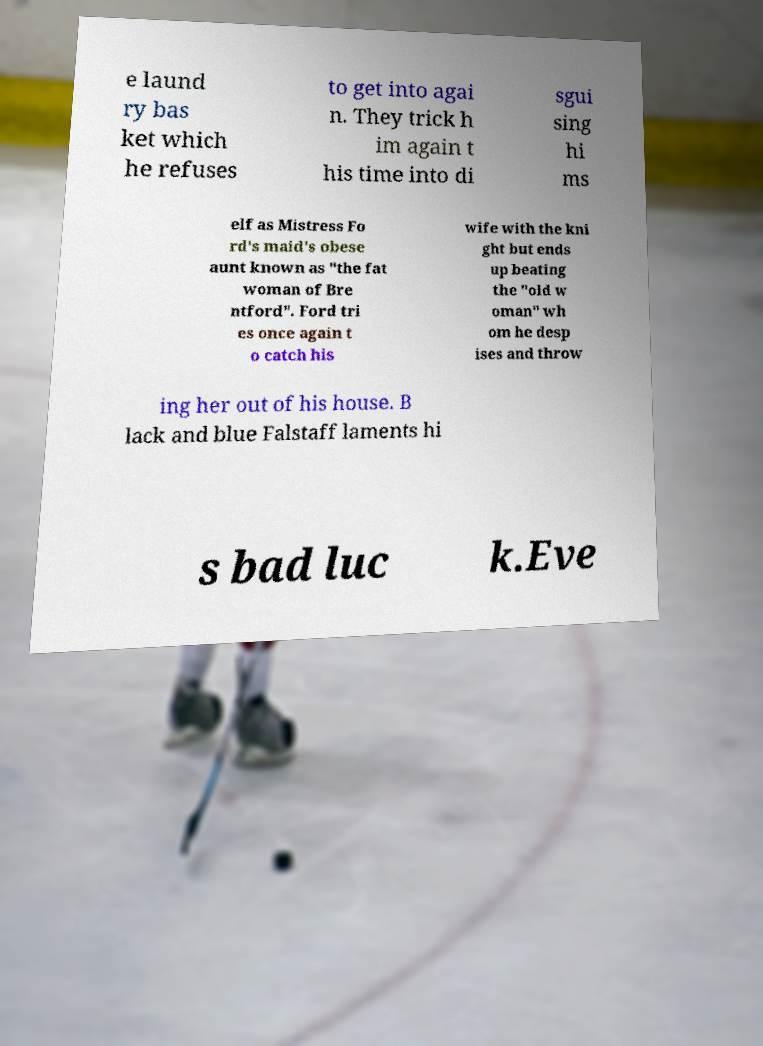Could you extract and type out the text from this image? e laund ry bas ket which he refuses to get into agai n. They trick h im again t his time into di sgui sing hi ms elf as Mistress Fo rd's maid's obese aunt known as "the fat woman of Bre ntford". Ford tri es once again t o catch his wife with the kni ght but ends up beating the "old w oman" wh om he desp ises and throw ing her out of his house. B lack and blue Falstaff laments hi s bad luc k.Eve 